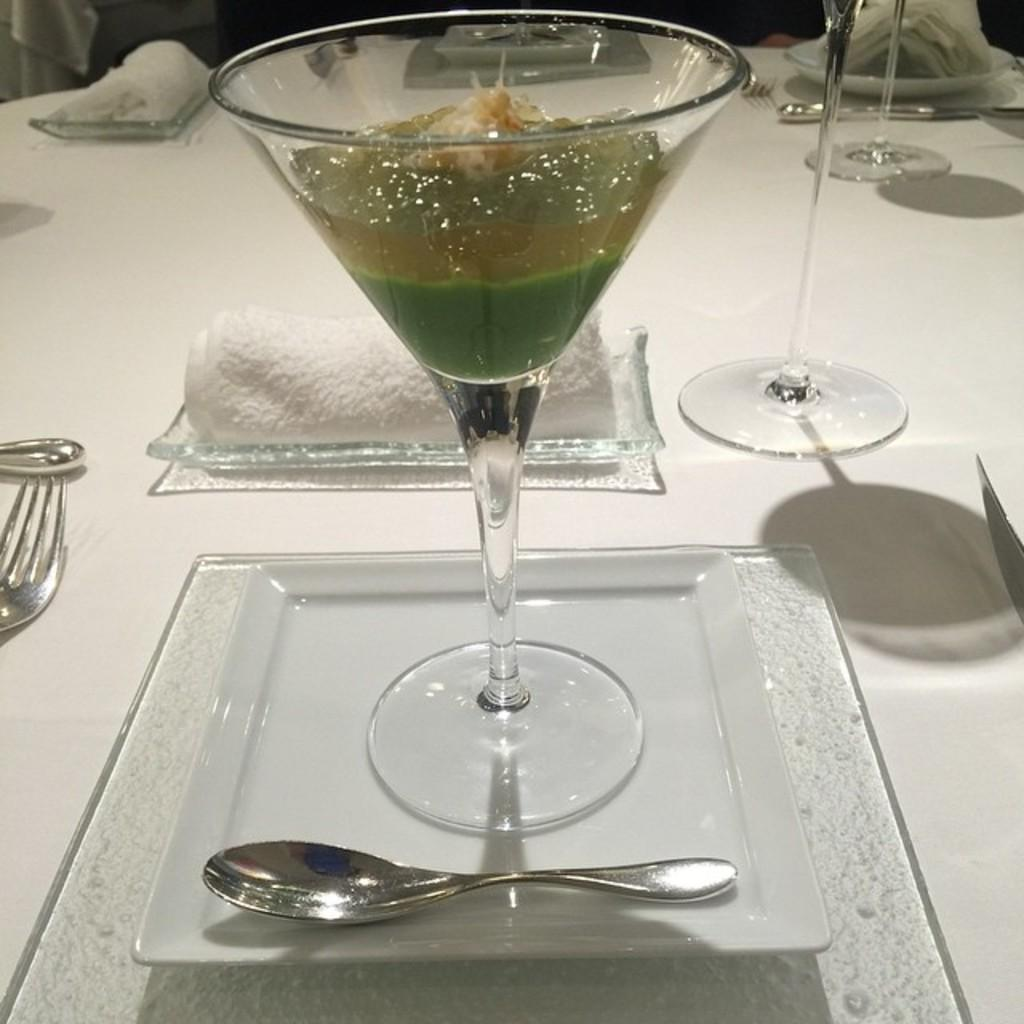What is present on the table in the image? There is a glass, a fork, and a napkin on the table in the image. Can you describe the glass in the image? The glass is kept on the table in the image. What other utensil can be seen on the table? There is a fork on the table. What might be used for cleaning or wiping in the image? A napkin is present on the table for cleaning or wiping. What type of screw can be seen on the table in the image? There is no screw present on the table in the image. What is the secretary doing in the image? There is no secretary present in the image. 